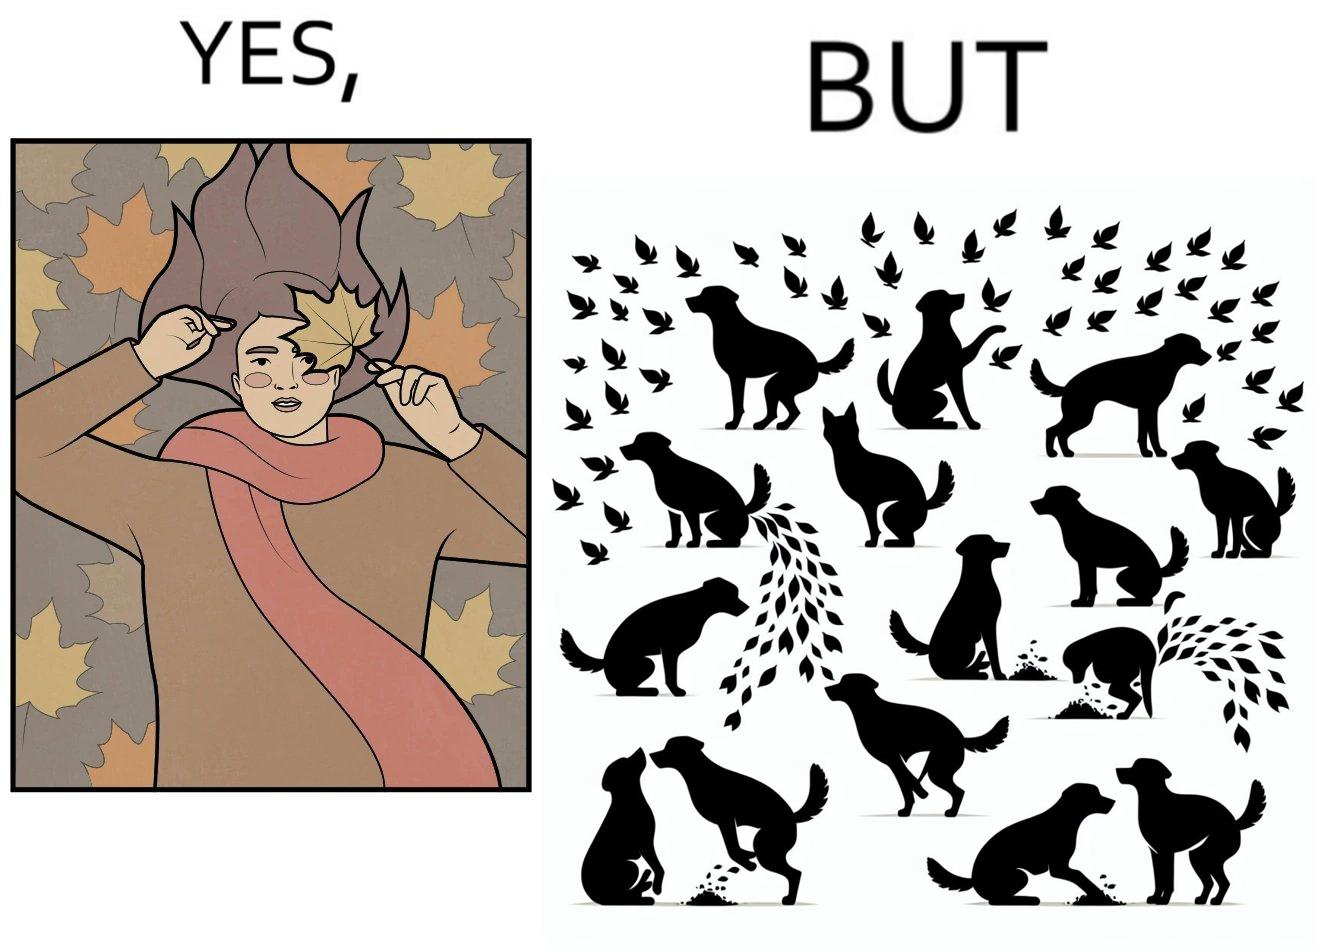Is this a satirical image? Yes, this image is satirical. 